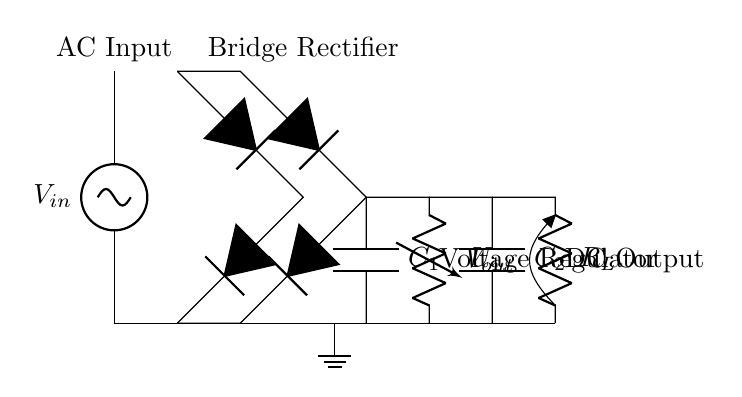What is the input voltage source labeled as? The input voltage source is labeled as V_in, indicating it’s the AC input voltage for the circuit.
Answer: V_in How many diodes are in the bridge rectifier? The bridge rectifier consists of 4 diodes arranged to convert the alternating current to direct current.
Answer: 4 What component smooths the output voltage? The component that smooths the output voltage is labeled C_1, representing a smoothing capacitor.
Answer: C_1 What is the function of the voltage regulator in the circuit? The voltage regulator, labeled U_1, regulates the output voltage to a specified level, ensuring stable voltage supply.
Answer: U_1 What type of output capacitor is used in this circuit? The circuit uses an output capacitor labeled C_2, which is placed after the voltage regulator to further smooth the output voltage.
Answer: C_2 Why is a bridge rectifier used instead of a single diode? A bridge rectifier is used instead of a single diode to allow current to flow in both directions, effectively converting the entire AC waveform into DC, maximizing efficiency.
Answer: Efficiency What is the purpose of the load resistor R_L in this circuit? The load resistor, labeled R_L, represents the load that consumes the output current, defining the load characteristics and helping to test the output voltage under load conditions.
Answer: R_L 